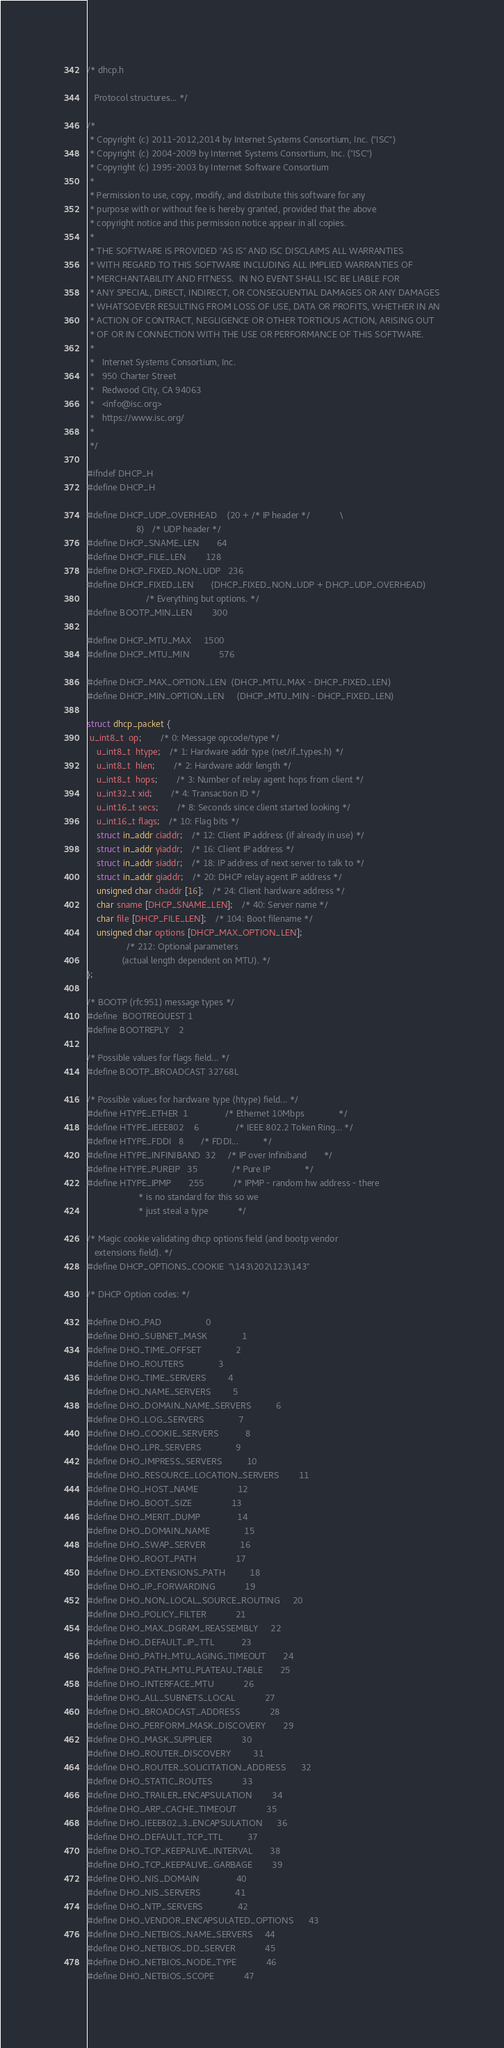Convert code to text. <code><loc_0><loc_0><loc_500><loc_500><_C_>/* dhcp.h

   Protocol structures... */

/*
 * Copyright (c) 2011-2012,2014 by Internet Systems Consortium, Inc. ("ISC")
 * Copyright (c) 2004-2009 by Internet Systems Consortium, Inc. ("ISC")
 * Copyright (c) 1995-2003 by Internet Software Consortium
 *
 * Permission to use, copy, modify, and distribute this software for any
 * purpose with or without fee is hereby granted, provided that the above
 * copyright notice and this permission notice appear in all copies.
 *
 * THE SOFTWARE IS PROVIDED "AS IS" AND ISC DISCLAIMS ALL WARRANTIES
 * WITH REGARD TO THIS SOFTWARE INCLUDING ALL IMPLIED WARRANTIES OF
 * MERCHANTABILITY AND FITNESS.  IN NO EVENT SHALL ISC BE LIABLE FOR
 * ANY SPECIAL, DIRECT, INDIRECT, OR CONSEQUENTIAL DAMAGES OR ANY DAMAGES
 * WHATSOEVER RESULTING FROM LOSS OF USE, DATA OR PROFITS, WHETHER IN AN
 * ACTION OF CONTRACT, NEGLIGENCE OR OTHER TORTIOUS ACTION, ARISING OUT
 * OF OR IN CONNECTION WITH THE USE OR PERFORMANCE OF THIS SOFTWARE.
 *
 *   Internet Systems Consortium, Inc.
 *   950 Charter Street
 *   Redwood City, CA 94063
 *   <info@isc.org>
 *   https://www.isc.org/
 *
 */

#ifndef DHCP_H
#define DHCP_H

#define DHCP_UDP_OVERHEAD	(20 + /* IP header */			\
			        8)   /* UDP header */
#define DHCP_SNAME_LEN		64
#define DHCP_FILE_LEN		128
#define DHCP_FIXED_NON_UDP	236
#define DHCP_FIXED_LEN		(DHCP_FIXED_NON_UDP + DHCP_UDP_OVERHEAD)
						/* Everything but options. */
#define BOOTP_MIN_LEN		300

#define DHCP_MTU_MAX		1500
#define DHCP_MTU_MIN            576

#define DHCP_MAX_OPTION_LEN	(DHCP_MTU_MAX - DHCP_FIXED_LEN)
#define DHCP_MIN_OPTION_LEN     (DHCP_MTU_MIN - DHCP_FIXED_LEN)

struct dhcp_packet {
 u_int8_t  op;		/* 0: Message opcode/type */
	u_int8_t  htype;	/* 1: Hardware addr type (net/if_types.h) */
	u_int8_t  hlen;		/* 2: Hardware addr length */
	u_int8_t  hops;		/* 3: Number of relay agent hops from client */
	u_int32_t xid;		/* 4: Transaction ID */
	u_int16_t secs;		/* 8: Seconds since client started looking */
	u_int16_t flags;	/* 10: Flag bits */
	struct in_addr ciaddr;	/* 12: Client IP address (if already in use) */
	struct in_addr yiaddr;	/* 16: Client IP address */
	struct in_addr siaddr;	/* 18: IP address of next server to talk to */
	struct in_addr giaddr;	/* 20: DHCP relay agent IP address */
	unsigned char chaddr [16];	/* 24: Client hardware address */
	char sname [DHCP_SNAME_LEN];	/* 40: Server name */
	char file [DHCP_FILE_LEN];	/* 104: Boot filename */
	unsigned char options [DHCP_MAX_OPTION_LEN];
				/* 212: Optional parameters
			  (actual length dependent on MTU). */
};

/* BOOTP (rfc951) message types */
#define	BOOTREQUEST	1
#define BOOTREPLY	2

/* Possible values for flags field... */
#define BOOTP_BROADCAST 32768L

/* Possible values for hardware type (htype) field... */
#define HTYPE_ETHER	1               /* Ethernet 10Mbps              */
#define HTYPE_IEEE802	6               /* IEEE 802.2 Token Ring...	*/
#define HTYPE_FDDI	8		/* FDDI...			*/
#define HTYPE_INFINIBAND  32		/* IP over Infiniband		*/
#define HTYPE_PUREIP   35              /* Pure IP              */
#define HTYPE_IPMP       255            /* IPMP - random hw address - there
					 * is no standard for this so we
					 * just steal a type            */

/* Magic cookie validating dhcp options field (and bootp vendor
   extensions field). */
#define DHCP_OPTIONS_COOKIE	"\143\202\123\143"

/* DHCP Option codes: */

#define DHO_PAD					0
#define DHO_SUBNET_MASK				1
#define DHO_TIME_OFFSET				2
#define DHO_ROUTERS				3
#define DHO_TIME_SERVERS			4
#define DHO_NAME_SERVERS			5
#define DHO_DOMAIN_NAME_SERVERS			6
#define DHO_LOG_SERVERS				7
#define DHO_COOKIE_SERVERS			8
#define DHO_LPR_SERVERS				9
#define DHO_IMPRESS_SERVERS			10
#define DHO_RESOURCE_LOCATION_SERVERS		11
#define DHO_HOST_NAME				12
#define DHO_BOOT_SIZE				13
#define DHO_MERIT_DUMP				14
#define DHO_DOMAIN_NAME				15
#define DHO_SWAP_SERVER				16
#define DHO_ROOT_PATH				17
#define DHO_EXTENSIONS_PATH			18
#define DHO_IP_FORWARDING			19
#define DHO_NON_LOCAL_SOURCE_ROUTING		20
#define DHO_POLICY_FILTER			21
#define DHO_MAX_DGRAM_REASSEMBLY		22
#define DHO_DEFAULT_IP_TTL			23
#define DHO_PATH_MTU_AGING_TIMEOUT		24
#define DHO_PATH_MTU_PLATEAU_TABLE		25
#define DHO_INTERFACE_MTU			26
#define DHO_ALL_SUBNETS_LOCAL			27
#define DHO_BROADCAST_ADDRESS			28
#define DHO_PERFORM_MASK_DISCOVERY		29
#define DHO_MASK_SUPPLIER			30
#define DHO_ROUTER_DISCOVERY			31
#define DHO_ROUTER_SOLICITATION_ADDRESS		32
#define DHO_STATIC_ROUTES			33
#define DHO_TRAILER_ENCAPSULATION		34
#define DHO_ARP_CACHE_TIMEOUT			35
#define DHO_IEEE802_3_ENCAPSULATION		36
#define DHO_DEFAULT_TCP_TTL			37
#define DHO_TCP_KEEPALIVE_INTERVAL		38
#define DHO_TCP_KEEPALIVE_GARBAGE		39
#define DHO_NIS_DOMAIN				40
#define DHO_NIS_SERVERS				41
#define DHO_NTP_SERVERS				42
#define DHO_VENDOR_ENCAPSULATED_OPTIONS		43
#define DHO_NETBIOS_NAME_SERVERS		44
#define DHO_NETBIOS_DD_SERVER			45
#define DHO_NETBIOS_NODE_TYPE			46
#define DHO_NETBIOS_SCOPE			47</code> 